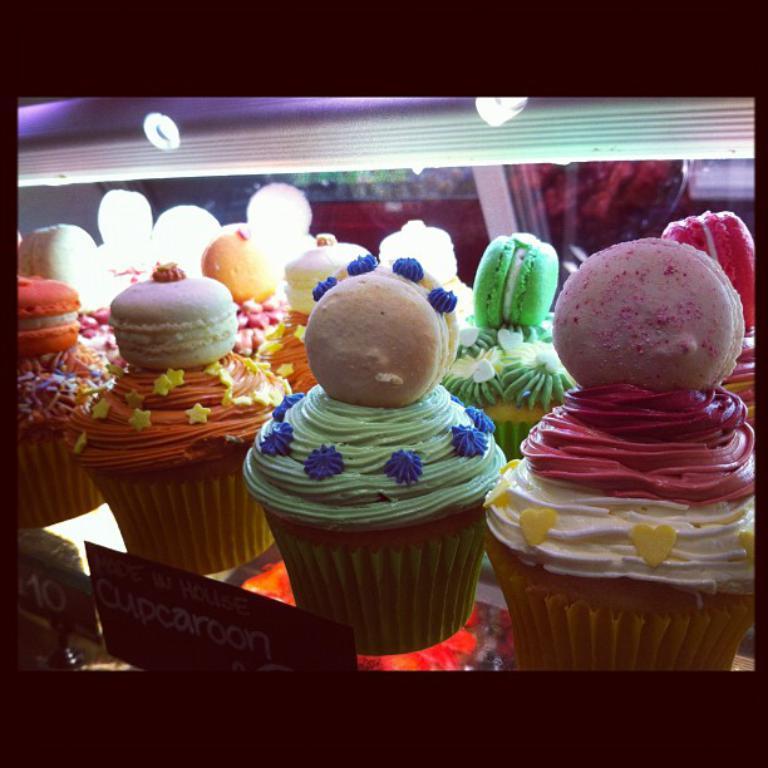Can you describe this image briefly? In the picture we can see some cupcakes which are placed in the rack and in the rack we can see some lights and the cakes are light green, pink, green and orange in color. 